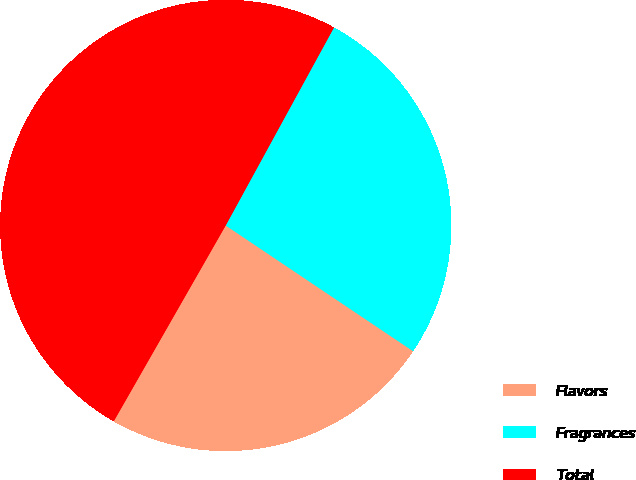Convert chart. <chart><loc_0><loc_0><loc_500><loc_500><pie_chart><fcel>Flavors<fcel>Fragrances<fcel>Total<nl><fcel>23.86%<fcel>26.44%<fcel>49.7%<nl></chart> 